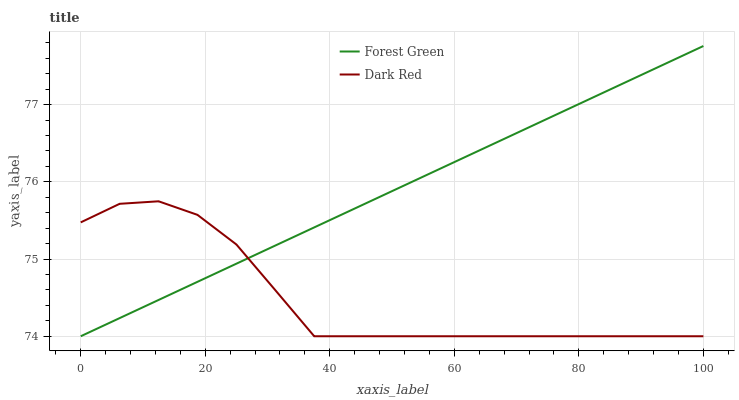Does Dark Red have the minimum area under the curve?
Answer yes or no. Yes. Does Forest Green have the maximum area under the curve?
Answer yes or no. Yes. Does Forest Green have the minimum area under the curve?
Answer yes or no. No. Is Forest Green the smoothest?
Answer yes or no. Yes. Is Dark Red the roughest?
Answer yes or no. Yes. Is Forest Green the roughest?
Answer yes or no. No. Does Dark Red have the lowest value?
Answer yes or no. Yes. Does Forest Green have the highest value?
Answer yes or no. Yes. Does Forest Green intersect Dark Red?
Answer yes or no. Yes. Is Forest Green less than Dark Red?
Answer yes or no. No. Is Forest Green greater than Dark Red?
Answer yes or no. No. 